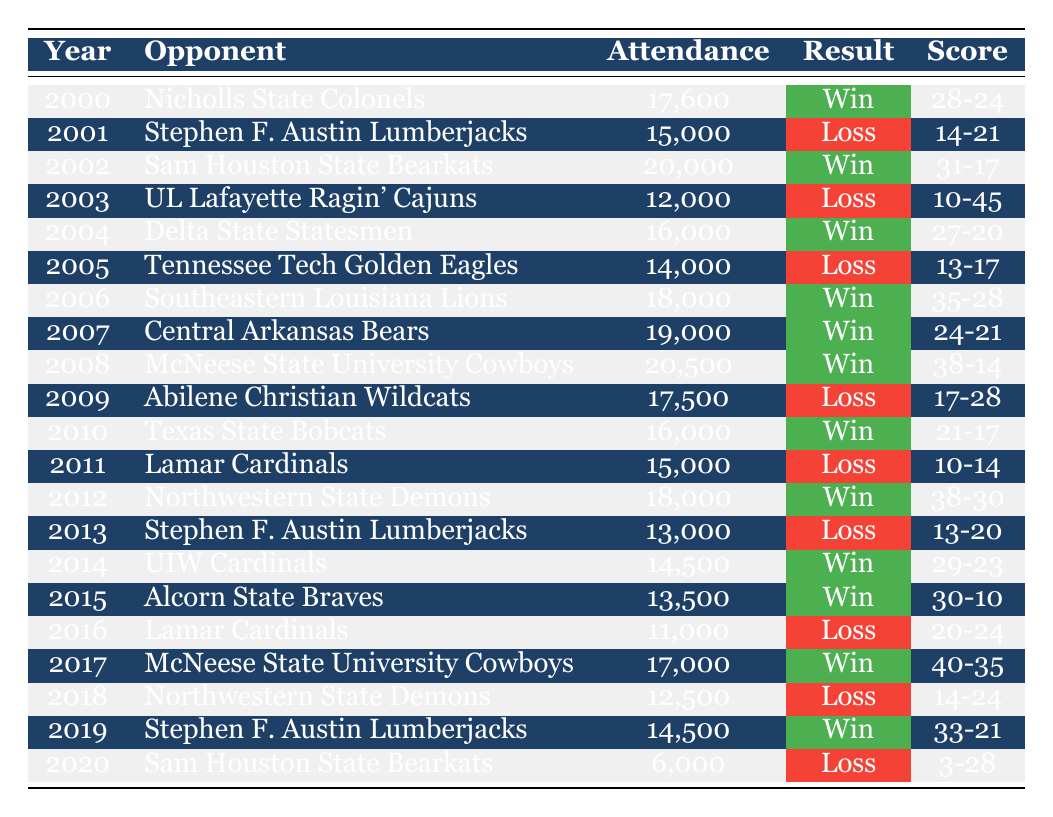What was the attendance for the game against the Nicholls State Colonels in 2000? The table indicates that in the year 2000, the attendance for the game against the Nicholls State Colonels was 17,600.
Answer: 17,600 Which year had the highest attendance? By examining the attendance figures in the table, the highest attendance recorded was in 2008, with 20,500 attendees for the game against McNeese State University Cowboys.
Answer: 20,500 How many games ended in a win from 2000 to 2020? Counting the 'Win' results in the table, there are 12 wins from 2000 to 2020.
Answer: 12 What is the average attendance over the years 2001 to 2020? The sum of attendances from 2001 to 2020 is (15,000 + 20,000 + 12,000 + 16,000 + 14,000 + 18,000 + 19,000 + 20,500 + 17,500 + 16,000 + 15,000 + 18,000 + 13,000 + 14,500 + 13,500 + 11,000 + 17,000 + 12,500 + 14,500 + 6,000) =  339,000. There are 20 data points, so dividing gives an average attendance of 339,000 / 20 = 16,950.
Answer: 16,950 How many games were lost by a score of 14 to 21? The table shows that in the year 2001, McNeese lost to Stephen F. Austin Lumberjacks with a score of 14-21, making it 1 game lost by that score.
Answer: 1 What was the change in attendance from 2007 to 2008? The attendance for McNeese State against Central Arkansas in 2007 was 19,000, while in 2008 against McNeese State Cowboys, it was 20,500. The change in attendance is 20,500 - 19,000 = 1,500.
Answer: 1,500 Which opponent had the lowest attendance in a game against McNeese State University? The opponent with the lowest attendance in the table is Sam Houston State Bearkats in 2020, with an attendance of 6,000.
Answer: 6,000 In how many seasons did McNeese State University achieve more than 18,000 in attendance? Reviewing the data, McNeese achieved more than 18,000 in attendance during 2002 (20,000), 2006 (18,000), 2007 (19,000), 2008 (20,500), and 2012 (18,000). That's a total of 5 seasons.
Answer: 5 Did McNeese State University ever have an attendance of 12,000 or more yet still lose the game? Yes, examining the table shows that in 2003, the attendance was 12,000, and McNeese lost that game against UL Lafayette with a score of 10-45.
Answer: Yes What was the average attendance during the years McNeese played the Stephen F. Austin Lumberjacks? The games against Stephen F. Austin Lumberjacks that appear in the table are in 2001 (15,000) and 2013 (13,000), summed up to 15,000 + 13,000 = 28,000. Dividing by 2 gives an average of 28,000 / 2 = 14,000.
Answer: 14,000 